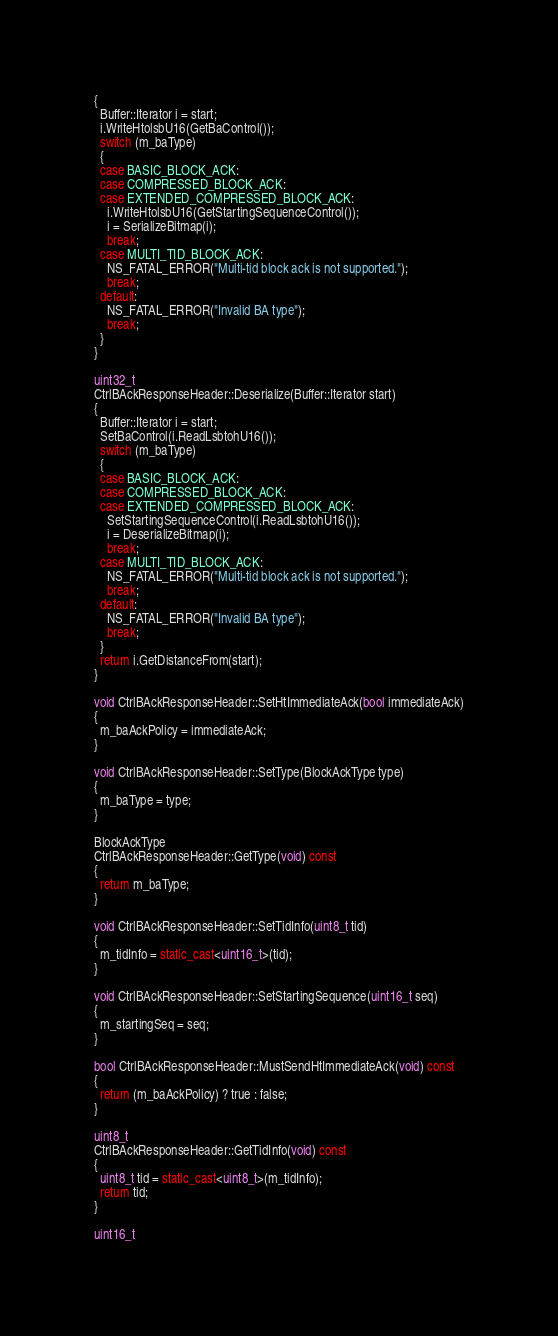<code> <loc_0><loc_0><loc_500><loc_500><_C++_>{
  Buffer::Iterator i = start;
  i.WriteHtolsbU16(GetBaControl());
  switch (m_baType)
  {
  case BASIC_BLOCK_ACK:
  case COMPRESSED_BLOCK_ACK:
  case EXTENDED_COMPRESSED_BLOCK_ACK:
    i.WriteHtolsbU16(GetStartingSequenceControl());
    i = SerializeBitmap(i);
    break;
  case MULTI_TID_BLOCK_ACK:
    NS_FATAL_ERROR("Multi-tid block ack is not supported.");
    break;
  default:
    NS_FATAL_ERROR("Invalid BA type");
    break;
  }
}

uint32_t
CtrlBAckResponseHeader::Deserialize(Buffer::Iterator start)
{
  Buffer::Iterator i = start;
  SetBaControl(i.ReadLsbtohU16());
  switch (m_baType)
  {
  case BASIC_BLOCK_ACK:
  case COMPRESSED_BLOCK_ACK:
  case EXTENDED_COMPRESSED_BLOCK_ACK:
    SetStartingSequenceControl(i.ReadLsbtohU16());
    i = DeserializeBitmap(i);
    break;
  case MULTI_TID_BLOCK_ACK:
    NS_FATAL_ERROR("Multi-tid block ack is not supported.");
    break;
  default:
    NS_FATAL_ERROR("Invalid BA type");
    break;
  }
  return i.GetDistanceFrom(start);
}

void CtrlBAckResponseHeader::SetHtImmediateAck(bool immediateAck)
{
  m_baAckPolicy = immediateAck;
}

void CtrlBAckResponseHeader::SetType(BlockAckType type)
{
  m_baType = type;
}

BlockAckType
CtrlBAckResponseHeader::GetType(void) const
{
  return m_baType;
}

void CtrlBAckResponseHeader::SetTidInfo(uint8_t tid)
{
  m_tidInfo = static_cast<uint16_t>(tid);
}

void CtrlBAckResponseHeader::SetStartingSequence(uint16_t seq)
{
  m_startingSeq = seq;
}

bool CtrlBAckResponseHeader::MustSendHtImmediateAck(void) const
{
  return (m_baAckPolicy) ? true : false;
}

uint8_t
CtrlBAckResponseHeader::GetTidInfo(void) const
{
  uint8_t tid = static_cast<uint8_t>(m_tidInfo);
  return tid;
}

uint16_t</code> 